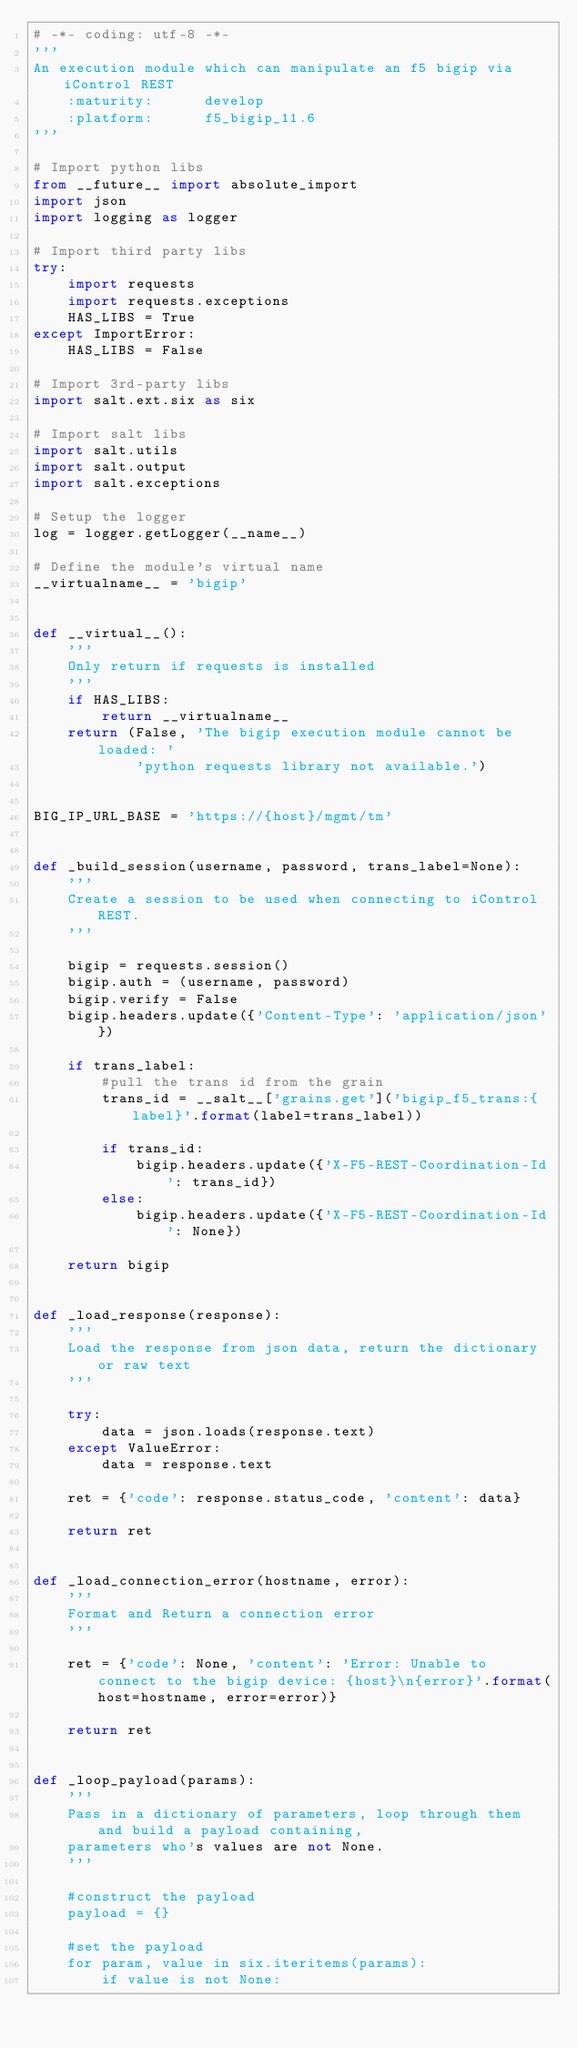<code> <loc_0><loc_0><loc_500><loc_500><_Python_># -*- coding: utf-8 -*-
'''
An execution module which can manipulate an f5 bigip via iControl REST
    :maturity:      develop
    :platform:      f5_bigip_11.6
'''

# Import python libs
from __future__ import absolute_import
import json
import logging as logger

# Import third party libs
try:
    import requests
    import requests.exceptions
    HAS_LIBS = True
except ImportError:
    HAS_LIBS = False

# Import 3rd-party libs
import salt.ext.six as six

# Import salt libs
import salt.utils
import salt.output
import salt.exceptions

# Setup the logger
log = logger.getLogger(__name__)

# Define the module's virtual name
__virtualname__ = 'bigip'


def __virtual__():
    '''
    Only return if requests is installed
    '''
    if HAS_LIBS:
        return __virtualname__
    return (False, 'The bigip execution module cannot be loaded: '
            'python requests library not available.')


BIG_IP_URL_BASE = 'https://{host}/mgmt/tm'


def _build_session(username, password, trans_label=None):
    '''
    Create a session to be used when connecting to iControl REST.
    '''

    bigip = requests.session()
    bigip.auth = (username, password)
    bigip.verify = False
    bigip.headers.update({'Content-Type': 'application/json'})

    if trans_label:
        #pull the trans id from the grain
        trans_id = __salt__['grains.get']('bigip_f5_trans:{label}'.format(label=trans_label))

        if trans_id:
            bigip.headers.update({'X-F5-REST-Coordination-Id': trans_id})
        else:
            bigip.headers.update({'X-F5-REST-Coordination-Id': None})

    return bigip


def _load_response(response):
    '''
    Load the response from json data, return the dictionary or raw text
    '''

    try:
        data = json.loads(response.text)
    except ValueError:
        data = response.text

    ret = {'code': response.status_code, 'content': data}

    return ret


def _load_connection_error(hostname, error):
    '''
    Format and Return a connection error
    '''

    ret = {'code': None, 'content': 'Error: Unable to connect to the bigip device: {host}\n{error}'.format(host=hostname, error=error)}

    return ret


def _loop_payload(params):
    '''
    Pass in a dictionary of parameters, loop through them and build a payload containing,
    parameters who's values are not None.
    '''

    #construct the payload
    payload = {}

    #set the payload
    for param, value in six.iteritems(params):
        if value is not None:</code> 